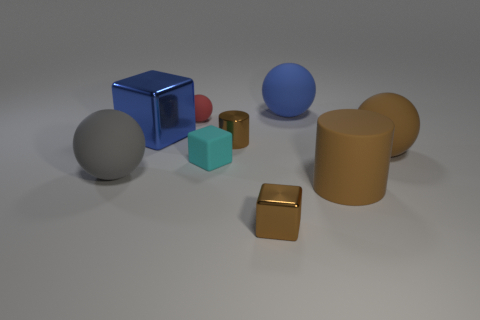Is the small cyan thing the same shape as the blue matte object? no 